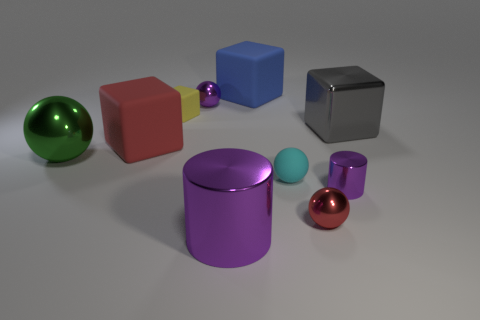Which object in the image appears to be the largest? The object that appears to be the largest is the purple cylindrical container situated in the center of the arrangement. 